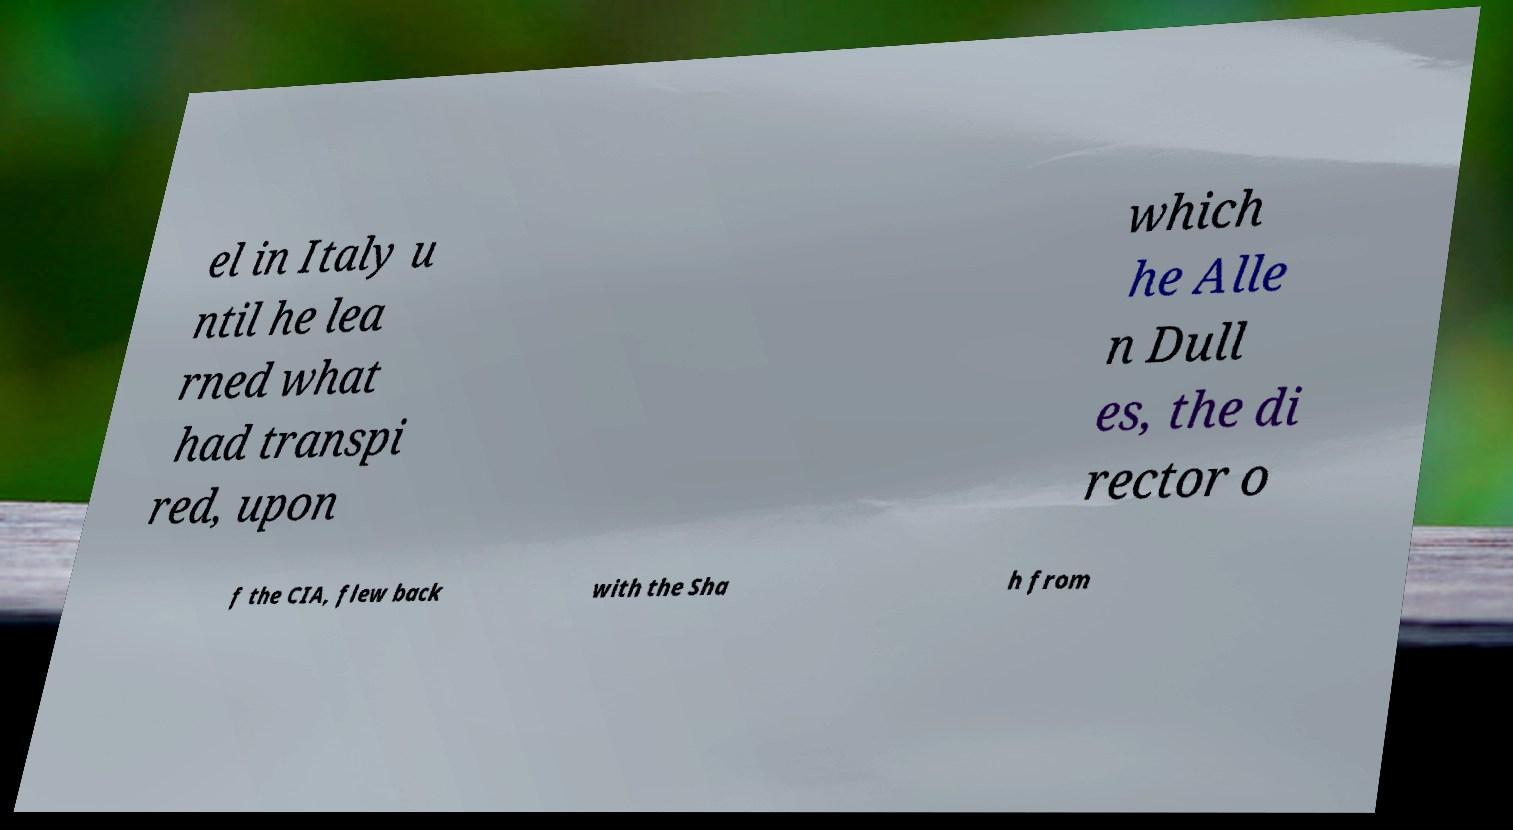Can you read and provide the text displayed in the image?This photo seems to have some interesting text. Can you extract and type it out for me? el in Italy u ntil he lea rned what had transpi red, upon which he Alle n Dull es, the di rector o f the CIA, flew back with the Sha h from 